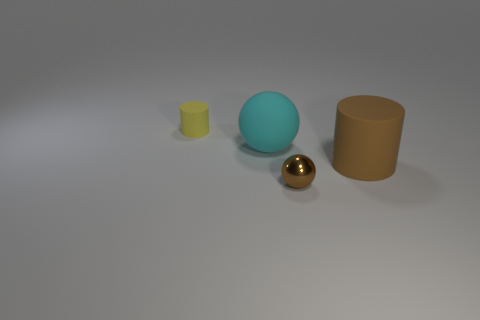Is there any other thing that has the same material as the brown ball?
Provide a succinct answer. No. Does the rubber cylinder that is in front of the yellow matte cylinder have the same color as the small matte thing?
Your answer should be compact. No. What number of small brown shiny objects are the same shape as the cyan rubber thing?
Keep it short and to the point. 1. What is the size of the brown thing that is made of the same material as the cyan ball?
Offer a very short reply. Large. There is a small thing behind the rubber thing that is to the right of the brown metal thing; are there any tiny yellow matte things in front of it?
Provide a succinct answer. No. Does the ball in front of the matte ball have the same size as the cyan matte ball?
Keep it short and to the point. No. What number of brown shiny objects are the same size as the yellow thing?
Ensure brevity in your answer.  1. There is a rubber cylinder that is the same color as the metallic object; what size is it?
Ensure brevity in your answer.  Large. Is the color of the rubber sphere the same as the tiny shiny thing?
Give a very brief answer. No. There is a cyan rubber thing; what shape is it?
Ensure brevity in your answer.  Sphere. 